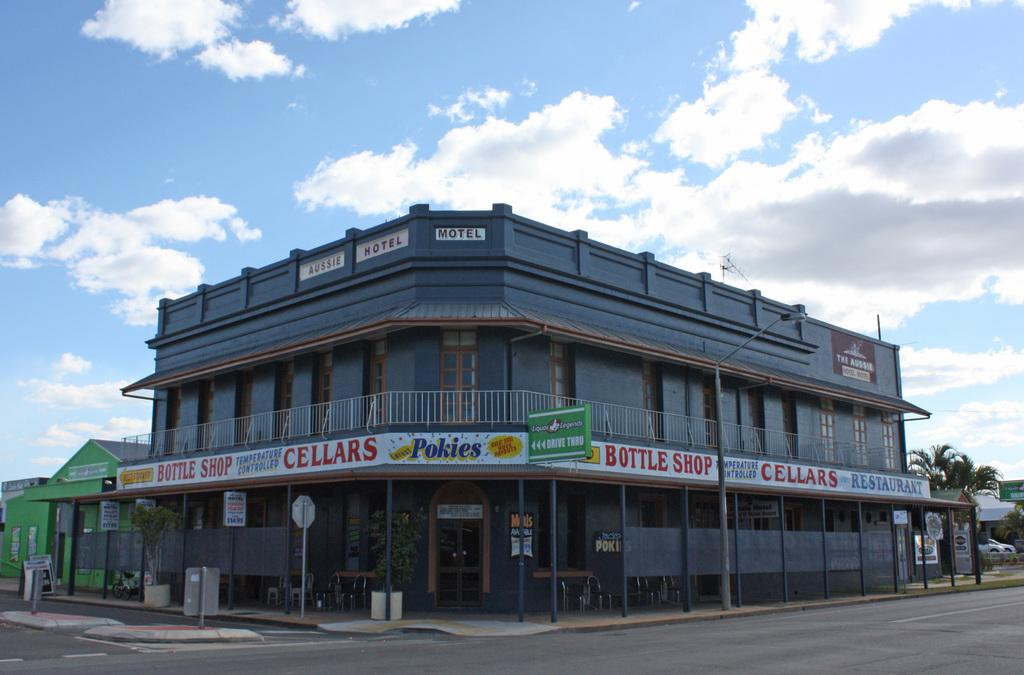What type of structures can be seen in the image? There are buildings in the image. What natural elements are present in the image? There are trees and plants in the image. What mode of transportation is visible in the image? There is a vehicle in the image. What type of advertising is present in the image? There is a hoarding in the image. What type of signage is present in the image? There are boards in the image. What type of street furniture is present in the image? There is a light pole in the image. What is the weather like in the image? The sky is cloudy in the image. Can you describe the behavior of the deer in the image? There are no deer present in the image. What is the existence of the image? The image itself exists, but the question seems to be asking about the existence of something within the image, which is not applicable since there are no deer present. 